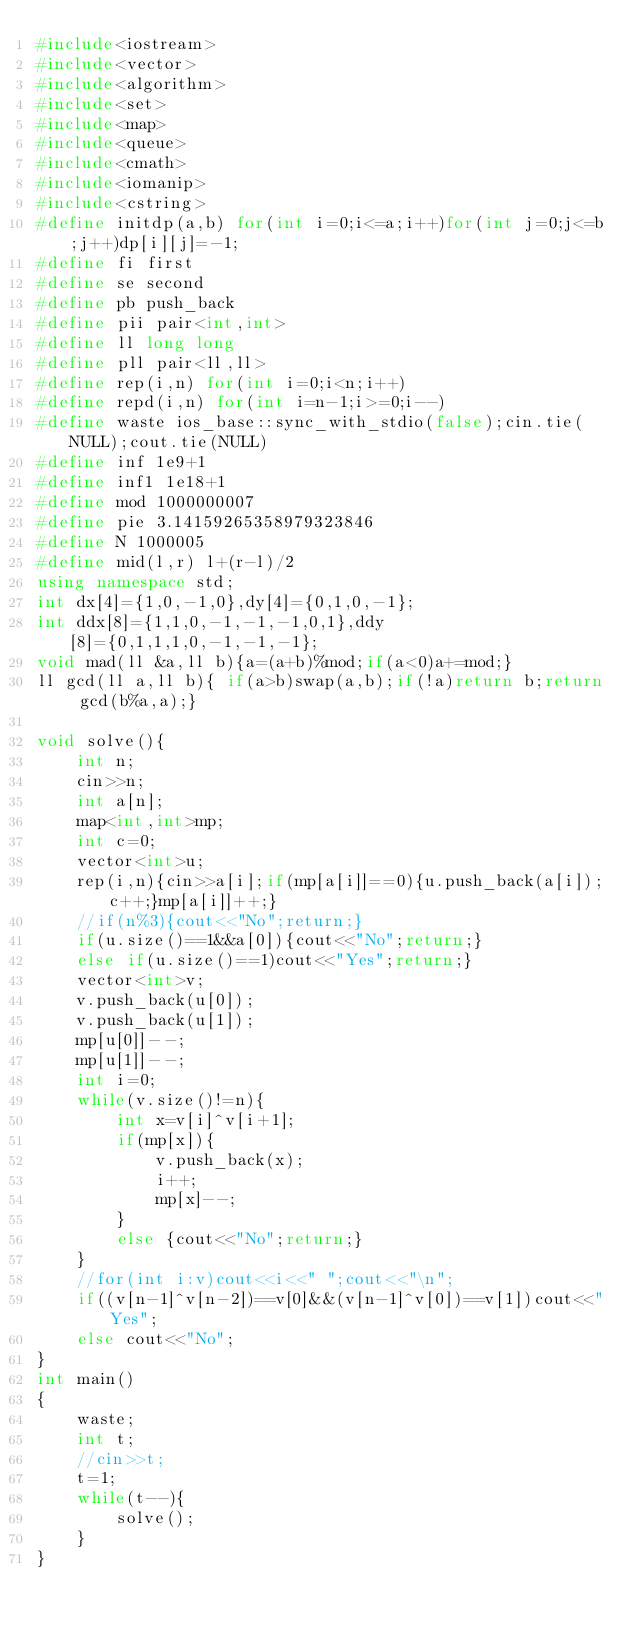<code> <loc_0><loc_0><loc_500><loc_500><_C++_>#include<iostream>
#include<vector>
#include<algorithm>
#include<set>
#include<map>
#include<queue>
#include<cmath>
#include<iomanip>
#include<cstring>
#define initdp(a,b) for(int i=0;i<=a;i++)for(int j=0;j<=b;j++)dp[i][j]=-1;
#define fi first
#define se second
#define pb push_back
#define pii pair<int,int>
#define ll long long
#define pll pair<ll,ll>
#define rep(i,n) for(int i=0;i<n;i++)
#define repd(i,n) for(int i=n-1;i>=0;i--)
#define waste ios_base::sync_with_stdio(false);cin.tie(NULL);cout.tie(NULL)
#define inf 1e9+1
#define inf1 1e18+1
#define mod 1000000007
#define pie 3.14159265358979323846
#define N 1000005
#define mid(l,r) l+(r-l)/2
using namespace std;
int dx[4]={1,0,-1,0},dy[4]={0,1,0,-1};
int ddx[8]={1,1,0,-1,-1,-1,0,1},ddy[8]={0,1,1,1,0,-1,-1,-1};
void mad(ll &a,ll b){a=(a+b)%mod;if(a<0)a+=mod;}
ll gcd(ll a,ll b){ if(a>b)swap(a,b);if(!a)return b;return gcd(b%a,a);}

void solve(){
	int n;
	cin>>n;
	int a[n];
	map<int,int>mp;
	int c=0;
	vector<int>u;
	rep(i,n){cin>>a[i];if(mp[a[i]]==0){u.push_back(a[i]);c++;}mp[a[i]]++;}
	//if(n%3){cout<<"No";return;}
	if(u.size()==1&&a[0]){cout<<"No";return;}
  	else if(u.size()==1)cout<<"Yes";return;}
	vector<int>v;
	v.push_back(u[0]);
	v.push_back(u[1]);
	mp[u[0]]--;
	mp[u[1]]--;
	int i=0;
	while(v.size()!=n){
		int x=v[i]^v[i+1];
		if(mp[x]){
			v.push_back(x);
			i++;
			mp[x]--;
		}
		else {cout<<"No";return;}
	}
	//for(int i:v)cout<<i<<" ";cout<<"\n";
	if((v[n-1]^v[n-2])==v[0]&&(v[n-1]^v[0])==v[1])cout<<"Yes";
	else cout<<"No";
}
int main()
{
	waste;
	int t;
	//cin>>t;
	t=1;
	while(t--){
		solve();
	}
}</code> 